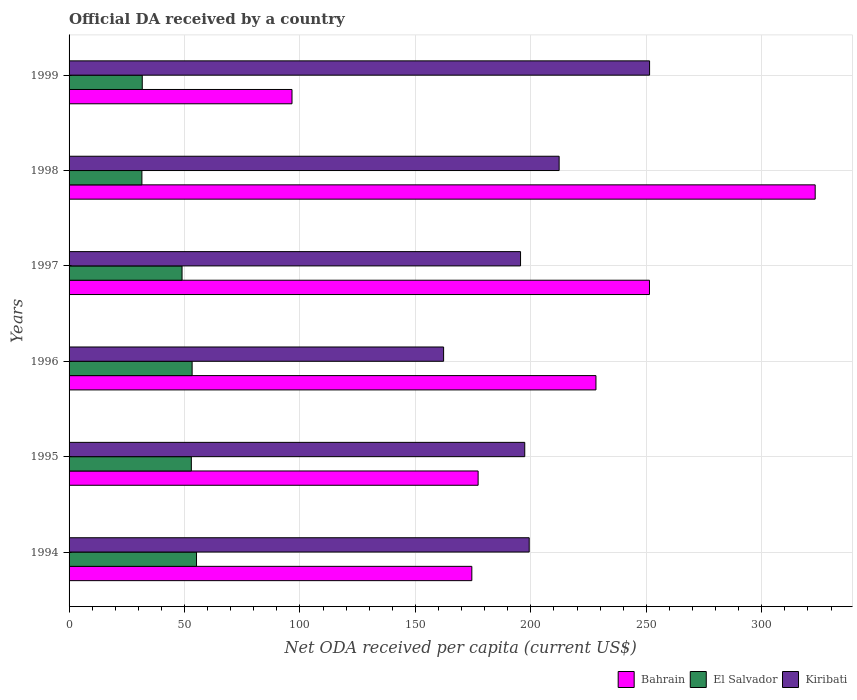How many groups of bars are there?
Keep it short and to the point. 6. Are the number of bars on each tick of the Y-axis equal?
Your answer should be very brief. Yes. What is the label of the 5th group of bars from the top?
Offer a terse response. 1995. In how many cases, is the number of bars for a given year not equal to the number of legend labels?
Provide a short and direct response. 0. What is the ODA received in in Kiribati in 1999?
Your answer should be very brief. 251.42. Across all years, what is the maximum ODA received in in El Salvador?
Offer a terse response. 55.2. Across all years, what is the minimum ODA received in in Bahrain?
Provide a succinct answer. 96.55. In which year was the ODA received in in El Salvador maximum?
Ensure brevity in your answer.  1994. In which year was the ODA received in in Kiribati minimum?
Make the answer very short. 1996. What is the total ODA received in in El Salvador in the graph?
Give a very brief answer. 273.63. What is the difference between the ODA received in in Bahrain in 1994 and that in 1997?
Ensure brevity in your answer.  -76.94. What is the difference between the ODA received in in Kiribati in 1994 and the ODA received in in Bahrain in 1996?
Your answer should be compact. -28.91. What is the average ODA received in in El Salvador per year?
Your answer should be very brief. 45.6. In the year 1999, what is the difference between the ODA received in in Kiribati and ODA received in in El Salvador?
Your response must be concise. 219.72. In how many years, is the ODA received in in Bahrain greater than 230 US$?
Give a very brief answer. 2. What is the ratio of the ODA received in in Bahrain in 1994 to that in 1996?
Your answer should be compact. 0.76. Is the ODA received in in Kiribati in 1994 less than that in 1998?
Ensure brevity in your answer.  Yes. What is the difference between the highest and the second highest ODA received in in El Salvador?
Keep it short and to the point. 1.9. What is the difference between the highest and the lowest ODA received in in El Salvador?
Make the answer very short. 23.65. What does the 3rd bar from the top in 1995 represents?
Provide a short and direct response. Bahrain. What does the 1st bar from the bottom in 1999 represents?
Ensure brevity in your answer.  Bahrain. How many years are there in the graph?
Keep it short and to the point. 6. Where does the legend appear in the graph?
Keep it short and to the point. Bottom right. What is the title of the graph?
Provide a succinct answer. Official DA received by a country. What is the label or title of the X-axis?
Provide a succinct answer. Net ODA received per capita (current US$). What is the Net ODA received per capita (current US$) of Bahrain in 1994?
Offer a very short reply. 174.43. What is the Net ODA received per capita (current US$) of El Salvador in 1994?
Your answer should be compact. 55.2. What is the Net ODA received per capita (current US$) of Kiribati in 1994?
Your answer should be compact. 199.29. What is the Net ODA received per capita (current US$) in Bahrain in 1995?
Provide a short and direct response. 177.16. What is the Net ODA received per capita (current US$) of El Salvador in 1995?
Make the answer very short. 52.96. What is the Net ODA received per capita (current US$) in Kiribati in 1995?
Make the answer very short. 197.36. What is the Net ODA received per capita (current US$) in Bahrain in 1996?
Offer a very short reply. 228.19. What is the Net ODA received per capita (current US$) of El Salvador in 1996?
Your response must be concise. 53.3. What is the Net ODA received per capita (current US$) in Kiribati in 1996?
Your response must be concise. 162.22. What is the Net ODA received per capita (current US$) of Bahrain in 1997?
Your response must be concise. 251.37. What is the Net ODA received per capita (current US$) in El Salvador in 1997?
Your answer should be compact. 48.93. What is the Net ODA received per capita (current US$) of Kiribati in 1997?
Offer a very short reply. 195.54. What is the Net ODA received per capita (current US$) of Bahrain in 1998?
Ensure brevity in your answer.  323.14. What is the Net ODA received per capita (current US$) of El Salvador in 1998?
Your response must be concise. 31.54. What is the Net ODA received per capita (current US$) in Kiribati in 1998?
Make the answer very short. 212.25. What is the Net ODA received per capita (current US$) of Bahrain in 1999?
Keep it short and to the point. 96.55. What is the Net ODA received per capita (current US$) in El Salvador in 1999?
Your answer should be very brief. 31.7. What is the Net ODA received per capita (current US$) of Kiribati in 1999?
Provide a succinct answer. 251.42. Across all years, what is the maximum Net ODA received per capita (current US$) of Bahrain?
Provide a short and direct response. 323.14. Across all years, what is the maximum Net ODA received per capita (current US$) in El Salvador?
Provide a succinct answer. 55.2. Across all years, what is the maximum Net ODA received per capita (current US$) of Kiribati?
Your response must be concise. 251.42. Across all years, what is the minimum Net ODA received per capita (current US$) in Bahrain?
Ensure brevity in your answer.  96.55. Across all years, what is the minimum Net ODA received per capita (current US$) of El Salvador?
Make the answer very short. 31.54. Across all years, what is the minimum Net ODA received per capita (current US$) of Kiribati?
Provide a succinct answer. 162.22. What is the total Net ODA received per capita (current US$) of Bahrain in the graph?
Your answer should be compact. 1250.86. What is the total Net ODA received per capita (current US$) of El Salvador in the graph?
Make the answer very short. 273.63. What is the total Net ODA received per capita (current US$) in Kiribati in the graph?
Offer a very short reply. 1218.06. What is the difference between the Net ODA received per capita (current US$) in Bahrain in 1994 and that in 1995?
Make the answer very short. -2.73. What is the difference between the Net ODA received per capita (current US$) in El Salvador in 1994 and that in 1995?
Your answer should be compact. 2.24. What is the difference between the Net ODA received per capita (current US$) in Kiribati in 1994 and that in 1995?
Offer a terse response. 1.93. What is the difference between the Net ODA received per capita (current US$) of Bahrain in 1994 and that in 1996?
Make the answer very short. -53.76. What is the difference between the Net ODA received per capita (current US$) in El Salvador in 1994 and that in 1996?
Provide a short and direct response. 1.9. What is the difference between the Net ODA received per capita (current US$) of Kiribati in 1994 and that in 1996?
Your answer should be compact. 37.07. What is the difference between the Net ODA received per capita (current US$) in Bahrain in 1994 and that in 1997?
Ensure brevity in your answer.  -76.94. What is the difference between the Net ODA received per capita (current US$) of El Salvador in 1994 and that in 1997?
Provide a succinct answer. 6.26. What is the difference between the Net ODA received per capita (current US$) in Kiribati in 1994 and that in 1997?
Keep it short and to the point. 3.75. What is the difference between the Net ODA received per capita (current US$) in Bahrain in 1994 and that in 1998?
Your answer should be very brief. -148.71. What is the difference between the Net ODA received per capita (current US$) in El Salvador in 1994 and that in 1998?
Your answer should be compact. 23.65. What is the difference between the Net ODA received per capita (current US$) in Kiribati in 1994 and that in 1998?
Ensure brevity in your answer.  -12.96. What is the difference between the Net ODA received per capita (current US$) of Bahrain in 1994 and that in 1999?
Your response must be concise. 77.88. What is the difference between the Net ODA received per capita (current US$) in El Salvador in 1994 and that in 1999?
Make the answer very short. 23.5. What is the difference between the Net ODA received per capita (current US$) in Kiribati in 1994 and that in 1999?
Your answer should be very brief. -52.13. What is the difference between the Net ODA received per capita (current US$) in Bahrain in 1995 and that in 1996?
Your response must be concise. -51.04. What is the difference between the Net ODA received per capita (current US$) in El Salvador in 1995 and that in 1996?
Keep it short and to the point. -0.34. What is the difference between the Net ODA received per capita (current US$) of Kiribati in 1995 and that in 1996?
Provide a short and direct response. 35.14. What is the difference between the Net ODA received per capita (current US$) of Bahrain in 1995 and that in 1997?
Keep it short and to the point. -74.21. What is the difference between the Net ODA received per capita (current US$) in El Salvador in 1995 and that in 1997?
Provide a short and direct response. 4.02. What is the difference between the Net ODA received per capita (current US$) of Kiribati in 1995 and that in 1997?
Offer a very short reply. 1.82. What is the difference between the Net ODA received per capita (current US$) in Bahrain in 1995 and that in 1998?
Offer a very short reply. -145.98. What is the difference between the Net ODA received per capita (current US$) in El Salvador in 1995 and that in 1998?
Your answer should be compact. 21.41. What is the difference between the Net ODA received per capita (current US$) in Kiribati in 1995 and that in 1998?
Your answer should be very brief. -14.89. What is the difference between the Net ODA received per capita (current US$) of Bahrain in 1995 and that in 1999?
Your answer should be compact. 80.61. What is the difference between the Net ODA received per capita (current US$) in El Salvador in 1995 and that in 1999?
Give a very brief answer. 21.26. What is the difference between the Net ODA received per capita (current US$) in Kiribati in 1995 and that in 1999?
Make the answer very short. -54.06. What is the difference between the Net ODA received per capita (current US$) of Bahrain in 1996 and that in 1997?
Provide a succinct answer. -23.18. What is the difference between the Net ODA received per capita (current US$) in El Salvador in 1996 and that in 1997?
Provide a short and direct response. 4.36. What is the difference between the Net ODA received per capita (current US$) in Kiribati in 1996 and that in 1997?
Ensure brevity in your answer.  -33.32. What is the difference between the Net ODA received per capita (current US$) of Bahrain in 1996 and that in 1998?
Ensure brevity in your answer.  -94.95. What is the difference between the Net ODA received per capita (current US$) in El Salvador in 1996 and that in 1998?
Keep it short and to the point. 21.75. What is the difference between the Net ODA received per capita (current US$) in Kiribati in 1996 and that in 1998?
Your answer should be compact. -50.03. What is the difference between the Net ODA received per capita (current US$) of Bahrain in 1996 and that in 1999?
Offer a very short reply. 131.64. What is the difference between the Net ODA received per capita (current US$) of El Salvador in 1996 and that in 1999?
Give a very brief answer. 21.6. What is the difference between the Net ODA received per capita (current US$) of Kiribati in 1996 and that in 1999?
Offer a terse response. -89.2. What is the difference between the Net ODA received per capita (current US$) in Bahrain in 1997 and that in 1998?
Your answer should be very brief. -71.77. What is the difference between the Net ODA received per capita (current US$) in El Salvador in 1997 and that in 1998?
Provide a succinct answer. 17.39. What is the difference between the Net ODA received per capita (current US$) of Kiribati in 1997 and that in 1998?
Offer a terse response. -16.71. What is the difference between the Net ODA received per capita (current US$) of Bahrain in 1997 and that in 1999?
Your response must be concise. 154.82. What is the difference between the Net ODA received per capita (current US$) of El Salvador in 1997 and that in 1999?
Your response must be concise. 17.23. What is the difference between the Net ODA received per capita (current US$) in Kiribati in 1997 and that in 1999?
Offer a terse response. -55.88. What is the difference between the Net ODA received per capita (current US$) in Bahrain in 1998 and that in 1999?
Your answer should be compact. 226.59. What is the difference between the Net ODA received per capita (current US$) in El Salvador in 1998 and that in 1999?
Make the answer very short. -0.16. What is the difference between the Net ODA received per capita (current US$) in Kiribati in 1998 and that in 1999?
Your answer should be compact. -39.17. What is the difference between the Net ODA received per capita (current US$) of Bahrain in 1994 and the Net ODA received per capita (current US$) of El Salvador in 1995?
Offer a very short reply. 121.48. What is the difference between the Net ODA received per capita (current US$) in Bahrain in 1994 and the Net ODA received per capita (current US$) in Kiribati in 1995?
Keep it short and to the point. -22.92. What is the difference between the Net ODA received per capita (current US$) of El Salvador in 1994 and the Net ODA received per capita (current US$) of Kiribati in 1995?
Your answer should be very brief. -142.16. What is the difference between the Net ODA received per capita (current US$) in Bahrain in 1994 and the Net ODA received per capita (current US$) in El Salvador in 1996?
Offer a very short reply. 121.14. What is the difference between the Net ODA received per capita (current US$) in Bahrain in 1994 and the Net ODA received per capita (current US$) in Kiribati in 1996?
Your response must be concise. 12.22. What is the difference between the Net ODA received per capita (current US$) of El Salvador in 1994 and the Net ODA received per capita (current US$) of Kiribati in 1996?
Ensure brevity in your answer.  -107.02. What is the difference between the Net ODA received per capita (current US$) in Bahrain in 1994 and the Net ODA received per capita (current US$) in El Salvador in 1997?
Offer a very short reply. 125.5. What is the difference between the Net ODA received per capita (current US$) in Bahrain in 1994 and the Net ODA received per capita (current US$) in Kiribati in 1997?
Offer a very short reply. -21.1. What is the difference between the Net ODA received per capita (current US$) of El Salvador in 1994 and the Net ODA received per capita (current US$) of Kiribati in 1997?
Offer a very short reply. -140.34. What is the difference between the Net ODA received per capita (current US$) in Bahrain in 1994 and the Net ODA received per capita (current US$) in El Salvador in 1998?
Provide a succinct answer. 142.89. What is the difference between the Net ODA received per capita (current US$) in Bahrain in 1994 and the Net ODA received per capita (current US$) in Kiribati in 1998?
Ensure brevity in your answer.  -37.81. What is the difference between the Net ODA received per capita (current US$) in El Salvador in 1994 and the Net ODA received per capita (current US$) in Kiribati in 1998?
Make the answer very short. -157.05. What is the difference between the Net ODA received per capita (current US$) in Bahrain in 1994 and the Net ODA received per capita (current US$) in El Salvador in 1999?
Your answer should be very brief. 142.73. What is the difference between the Net ODA received per capita (current US$) in Bahrain in 1994 and the Net ODA received per capita (current US$) in Kiribati in 1999?
Ensure brevity in your answer.  -76.99. What is the difference between the Net ODA received per capita (current US$) of El Salvador in 1994 and the Net ODA received per capita (current US$) of Kiribati in 1999?
Make the answer very short. -196.22. What is the difference between the Net ODA received per capita (current US$) of Bahrain in 1995 and the Net ODA received per capita (current US$) of El Salvador in 1996?
Your answer should be compact. 123.86. What is the difference between the Net ODA received per capita (current US$) of Bahrain in 1995 and the Net ODA received per capita (current US$) of Kiribati in 1996?
Keep it short and to the point. 14.94. What is the difference between the Net ODA received per capita (current US$) in El Salvador in 1995 and the Net ODA received per capita (current US$) in Kiribati in 1996?
Keep it short and to the point. -109.26. What is the difference between the Net ODA received per capita (current US$) of Bahrain in 1995 and the Net ODA received per capita (current US$) of El Salvador in 1997?
Offer a very short reply. 128.23. What is the difference between the Net ODA received per capita (current US$) of Bahrain in 1995 and the Net ODA received per capita (current US$) of Kiribati in 1997?
Your answer should be compact. -18.38. What is the difference between the Net ODA received per capita (current US$) of El Salvador in 1995 and the Net ODA received per capita (current US$) of Kiribati in 1997?
Offer a terse response. -142.58. What is the difference between the Net ODA received per capita (current US$) of Bahrain in 1995 and the Net ODA received per capita (current US$) of El Salvador in 1998?
Ensure brevity in your answer.  145.62. What is the difference between the Net ODA received per capita (current US$) of Bahrain in 1995 and the Net ODA received per capita (current US$) of Kiribati in 1998?
Offer a very short reply. -35.09. What is the difference between the Net ODA received per capita (current US$) of El Salvador in 1995 and the Net ODA received per capita (current US$) of Kiribati in 1998?
Make the answer very short. -159.29. What is the difference between the Net ODA received per capita (current US$) of Bahrain in 1995 and the Net ODA received per capita (current US$) of El Salvador in 1999?
Give a very brief answer. 145.46. What is the difference between the Net ODA received per capita (current US$) of Bahrain in 1995 and the Net ODA received per capita (current US$) of Kiribati in 1999?
Make the answer very short. -74.26. What is the difference between the Net ODA received per capita (current US$) in El Salvador in 1995 and the Net ODA received per capita (current US$) in Kiribati in 1999?
Your response must be concise. -198.46. What is the difference between the Net ODA received per capita (current US$) of Bahrain in 1996 and the Net ODA received per capita (current US$) of El Salvador in 1997?
Ensure brevity in your answer.  179.26. What is the difference between the Net ODA received per capita (current US$) in Bahrain in 1996 and the Net ODA received per capita (current US$) in Kiribati in 1997?
Offer a very short reply. 32.66. What is the difference between the Net ODA received per capita (current US$) in El Salvador in 1996 and the Net ODA received per capita (current US$) in Kiribati in 1997?
Offer a terse response. -142.24. What is the difference between the Net ODA received per capita (current US$) in Bahrain in 1996 and the Net ODA received per capita (current US$) in El Salvador in 1998?
Your answer should be compact. 196.65. What is the difference between the Net ODA received per capita (current US$) of Bahrain in 1996 and the Net ODA received per capita (current US$) of Kiribati in 1998?
Ensure brevity in your answer.  15.95. What is the difference between the Net ODA received per capita (current US$) of El Salvador in 1996 and the Net ODA received per capita (current US$) of Kiribati in 1998?
Your answer should be compact. -158.95. What is the difference between the Net ODA received per capita (current US$) in Bahrain in 1996 and the Net ODA received per capita (current US$) in El Salvador in 1999?
Your answer should be compact. 196.49. What is the difference between the Net ODA received per capita (current US$) in Bahrain in 1996 and the Net ODA received per capita (current US$) in Kiribati in 1999?
Offer a terse response. -23.22. What is the difference between the Net ODA received per capita (current US$) in El Salvador in 1996 and the Net ODA received per capita (current US$) in Kiribati in 1999?
Make the answer very short. -198.12. What is the difference between the Net ODA received per capita (current US$) in Bahrain in 1997 and the Net ODA received per capita (current US$) in El Salvador in 1998?
Provide a short and direct response. 219.83. What is the difference between the Net ODA received per capita (current US$) of Bahrain in 1997 and the Net ODA received per capita (current US$) of Kiribati in 1998?
Offer a terse response. 39.13. What is the difference between the Net ODA received per capita (current US$) in El Salvador in 1997 and the Net ODA received per capita (current US$) in Kiribati in 1998?
Offer a very short reply. -163.31. What is the difference between the Net ODA received per capita (current US$) of Bahrain in 1997 and the Net ODA received per capita (current US$) of El Salvador in 1999?
Your answer should be very brief. 219.67. What is the difference between the Net ODA received per capita (current US$) of Bahrain in 1997 and the Net ODA received per capita (current US$) of Kiribati in 1999?
Offer a terse response. -0.05. What is the difference between the Net ODA received per capita (current US$) of El Salvador in 1997 and the Net ODA received per capita (current US$) of Kiribati in 1999?
Your answer should be very brief. -202.49. What is the difference between the Net ODA received per capita (current US$) in Bahrain in 1998 and the Net ODA received per capita (current US$) in El Salvador in 1999?
Your response must be concise. 291.44. What is the difference between the Net ODA received per capita (current US$) of Bahrain in 1998 and the Net ODA received per capita (current US$) of Kiribati in 1999?
Provide a succinct answer. 71.72. What is the difference between the Net ODA received per capita (current US$) of El Salvador in 1998 and the Net ODA received per capita (current US$) of Kiribati in 1999?
Make the answer very short. -219.88. What is the average Net ODA received per capita (current US$) of Bahrain per year?
Your answer should be very brief. 208.48. What is the average Net ODA received per capita (current US$) of El Salvador per year?
Offer a very short reply. 45.6. What is the average Net ODA received per capita (current US$) in Kiribati per year?
Make the answer very short. 203.01. In the year 1994, what is the difference between the Net ODA received per capita (current US$) in Bahrain and Net ODA received per capita (current US$) in El Salvador?
Offer a very short reply. 119.24. In the year 1994, what is the difference between the Net ODA received per capita (current US$) of Bahrain and Net ODA received per capita (current US$) of Kiribati?
Your response must be concise. -24.85. In the year 1994, what is the difference between the Net ODA received per capita (current US$) in El Salvador and Net ODA received per capita (current US$) in Kiribati?
Your answer should be very brief. -144.09. In the year 1995, what is the difference between the Net ODA received per capita (current US$) in Bahrain and Net ODA received per capita (current US$) in El Salvador?
Offer a terse response. 124.2. In the year 1995, what is the difference between the Net ODA received per capita (current US$) of Bahrain and Net ODA received per capita (current US$) of Kiribati?
Your response must be concise. -20.2. In the year 1995, what is the difference between the Net ODA received per capita (current US$) in El Salvador and Net ODA received per capita (current US$) in Kiribati?
Make the answer very short. -144.4. In the year 1996, what is the difference between the Net ODA received per capita (current US$) of Bahrain and Net ODA received per capita (current US$) of El Salvador?
Give a very brief answer. 174.9. In the year 1996, what is the difference between the Net ODA received per capita (current US$) in Bahrain and Net ODA received per capita (current US$) in Kiribati?
Provide a short and direct response. 65.98. In the year 1996, what is the difference between the Net ODA received per capita (current US$) in El Salvador and Net ODA received per capita (current US$) in Kiribati?
Offer a very short reply. -108.92. In the year 1997, what is the difference between the Net ODA received per capita (current US$) of Bahrain and Net ODA received per capita (current US$) of El Salvador?
Offer a terse response. 202.44. In the year 1997, what is the difference between the Net ODA received per capita (current US$) of Bahrain and Net ODA received per capita (current US$) of Kiribati?
Ensure brevity in your answer.  55.84. In the year 1997, what is the difference between the Net ODA received per capita (current US$) in El Salvador and Net ODA received per capita (current US$) in Kiribati?
Your answer should be compact. -146.6. In the year 1998, what is the difference between the Net ODA received per capita (current US$) in Bahrain and Net ODA received per capita (current US$) in El Salvador?
Make the answer very short. 291.6. In the year 1998, what is the difference between the Net ODA received per capita (current US$) in Bahrain and Net ODA received per capita (current US$) in Kiribati?
Offer a very short reply. 110.9. In the year 1998, what is the difference between the Net ODA received per capita (current US$) in El Salvador and Net ODA received per capita (current US$) in Kiribati?
Your answer should be very brief. -180.7. In the year 1999, what is the difference between the Net ODA received per capita (current US$) of Bahrain and Net ODA received per capita (current US$) of El Salvador?
Ensure brevity in your answer.  64.85. In the year 1999, what is the difference between the Net ODA received per capita (current US$) of Bahrain and Net ODA received per capita (current US$) of Kiribati?
Offer a very short reply. -154.87. In the year 1999, what is the difference between the Net ODA received per capita (current US$) of El Salvador and Net ODA received per capita (current US$) of Kiribati?
Keep it short and to the point. -219.72. What is the ratio of the Net ODA received per capita (current US$) in Bahrain in 1994 to that in 1995?
Keep it short and to the point. 0.98. What is the ratio of the Net ODA received per capita (current US$) in El Salvador in 1994 to that in 1995?
Make the answer very short. 1.04. What is the ratio of the Net ODA received per capita (current US$) of Kiribati in 1994 to that in 1995?
Your answer should be compact. 1.01. What is the ratio of the Net ODA received per capita (current US$) of Bahrain in 1994 to that in 1996?
Your response must be concise. 0.76. What is the ratio of the Net ODA received per capita (current US$) of El Salvador in 1994 to that in 1996?
Provide a short and direct response. 1.04. What is the ratio of the Net ODA received per capita (current US$) of Kiribati in 1994 to that in 1996?
Make the answer very short. 1.23. What is the ratio of the Net ODA received per capita (current US$) in Bahrain in 1994 to that in 1997?
Your answer should be very brief. 0.69. What is the ratio of the Net ODA received per capita (current US$) of El Salvador in 1994 to that in 1997?
Provide a succinct answer. 1.13. What is the ratio of the Net ODA received per capita (current US$) of Kiribati in 1994 to that in 1997?
Offer a very short reply. 1.02. What is the ratio of the Net ODA received per capita (current US$) of Bahrain in 1994 to that in 1998?
Give a very brief answer. 0.54. What is the ratio of the Net ODA received per capita (current US$) in El Salvador in 1994 to that in 1998?
Make the answer very short. 1.75. What is the ratio of the Net ODA received per capita (current US$) of Kiribati in 1994 to that in 1998?
Provide a succinct answer. 0.94. What is the ratio of the Net ODA received per capita (current US$) in Bahrain in 1994 to that in 1999?
Give a very brief answer. 1.81. What is the ratio of the Net ODA received per capita (current US$) in El Salvador in 1994 to that in 1999?
Keep it short and to the point. 1.74. What is the ratio of the Net ODA received per capita (current US$) of Kiribati in 1994 to that in 1999?
Offer a very short reply. 0.79. What is the ratio of the Net ODA received per capita (current US$) in Bahrain in 1995 to that in 1996?
Your answer should be compact. 0.78. What is the ratio of the Net ODA received per capita (current US$) in Kiribati in 1995 to that in 1996?
Your answer should be compact. 1.22. What is the ratio of the Net ODA received per capita (current US$) of Bahrain in 1995 to that in 1997?
Keep it short and to the point. 0.7. What is the ratio of the Net ODA received per capita (current US$) of El Salvador in 1995 to that in 1997?
Give a very brief answer. 1.08. What is the ratio of the Net ODA received per capita (current US$) of Kiribati in 1995 to that in 1997?
Provide a short and direct response. 1.01. What is the ratio of the Net ODA received per capita (current US$) of Bahrain in 1995 to that in 1998?
Your response must be concise. 0.55. What is the ratio of the Net ODA received per capita (current US$) of El Salvador in 1995 to that in 1998?
Your response must be concise. 1.68. What is the ratio of the Net ODA received per capita (current US$) in Kiribati in 1995 to that in 1998?
Your answer should be compact. 0.93. What is the ratio of the Net ODA received per capita (current US$) of Bahrain in 1995 to that in 1999?
Give a very brief answer. 1.83. What is the ratio of the Net ODA received per capita (current US$) of El Salvador in 1995 to that in 1999?
Ensure brevity in your answer.  1.67. What is the ratio of the Net ODA received per capita (current US$) in Kiribati in 1995 to that in 1999?
Offer a terse response. 0.79. What is the ratio of the Net ODA received per capita (current US$) of Bahrain in 1996 to that in 1997?
Ensure brevity in your answer.  0.91. What is the ratio of the Net ODA received per capita (current US$) in El Salvador in 1996 to that in 1997?
Your answer should be very brief. 1.09. What is the ratio of the Net ODA received per capita (current US$) of Kiribati in 1996 to that in 1997?
Ensure brevity in your answer.  0.83. What is the ratio of the Net ODA received per capita (current US$) of Bahrain in 1996 to that in 1998?
Offer a terse response. 0.71. What is the ratio of the Net ODA received per capita (current US$) of El Salvador in 1996 to that in 1998?
Keep it short and to the point. 1.69. What is the ratio of the Net ODA received per capita (current US$) in Kiribati in 1996 to that in 1998?
Offer a very short reply. 0.76. What is the ratio of the Net ODA received per capita (current US$) of Bahrain in 1996 to that in 1999?
Your response must be concise. 2.36. What is the ratio of the Net ODA received per capita (current US$) in El Salvador in 1996 to that in 1999?
Offer a terse response. 1.68. What is the ratio of the Net ODA received per capita (current US$) in Kiribati in 1996 to that in 1999?
Make the answer very short. 0.65. What is the ratio of the Net ODA received per capita (current US$) in Bahrain in 1997 to that in 1998?
Your answer should be very brief. 0.78. What is the ratio of the Net ODA received per capita (current US$) in El Salvador in 1997 to that in 1998?
Give a very brief answer. 1.55. What is the ratio of the Net ODA received per capita (current US$) in Kiribati in 1997 to that in 1998?
Make the answer very short. 0.92. What is the ratio of the Net ODA received per capita (current US$) of Bahrain in 1997 to that in 1999?
Your answer should be compact. 2.6. What is the ratio of the Net ODA received per capita (current US$) of El Salvador in 1997 to that in 1999?
Provide a short and direct response. 1.54. What is the ratio of the Net ODA received per capita (current US$) in Kiribati in 1997 to that in 1999?
Ensure brevity in your answer.  0.78. What is the ratio of the Net ODA received per capita (current US$) in Bahrain in 1998 to that in 1999?
Keep it short and to the point. 3.35. What is the ratio of the Net ODA received per capita (current US$) of Kiribati in 1998 to that in 1999?
Ensure brevity in your answer.  0.84. What is the difference between the highest and the second highest Net ODA received per capita (current US$) in Bahrain?
Keep it short and to the point. 71.77. What is the difference between the highest and the second highest Net ODA received per capita (current US$) of El Salvador?
Make the answer very short. 1.9. What is the difference between the highest and the second highest Net ODA received per capita (current US$) in Kiribati?
Offer a very short reply. 39.17. What is the difference between the highest and the lowest Net ODA received per capita (current US$) of Bahrain?
Provide a short and direct response. 226.59. What is the difference between the highest and the lowest Net ODA received per capita (current US$) of El Salvador?
Keep it short and to the point. 23.65. What is the difference between the highest and the lowest Net ODA received per capita (current US$) in Kiribati?
Your answer should be compact. 89.2. 